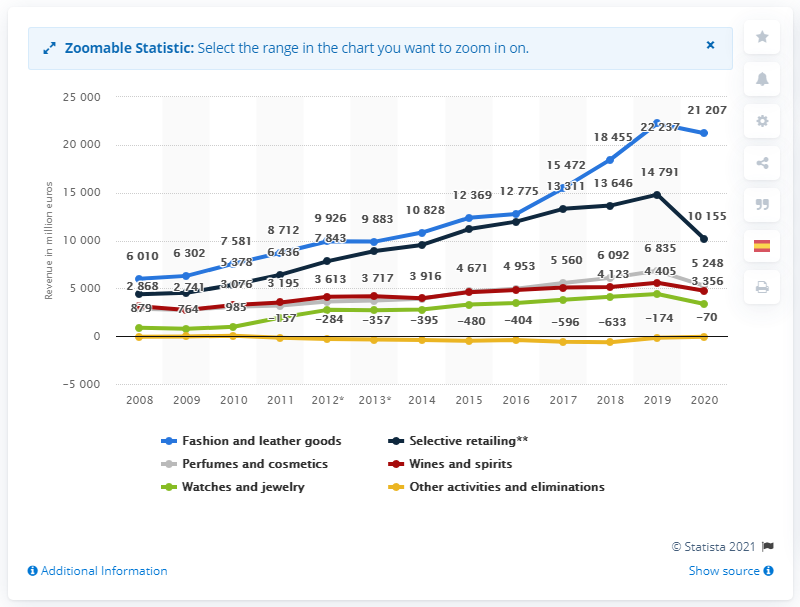Outline some significant characteristics in this image. In 2020, the LVMH Group's global revenue from their watches and jewelry segment was 335.6 million dollars. 